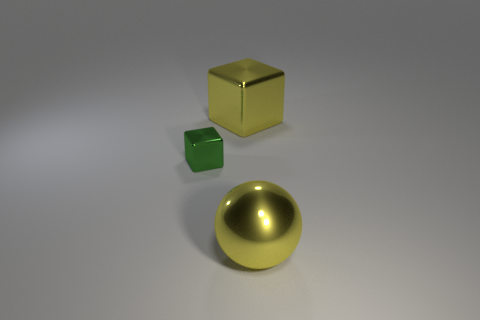Is the number of cubes greater than the number of green things? No, the number of cubes is not greater than the number of green things. There are two cubes in the image, one of which is green, and the other cube is gold. The other green object is a small rectangle, making the total number of green objects two, which equals the number of cubes. 